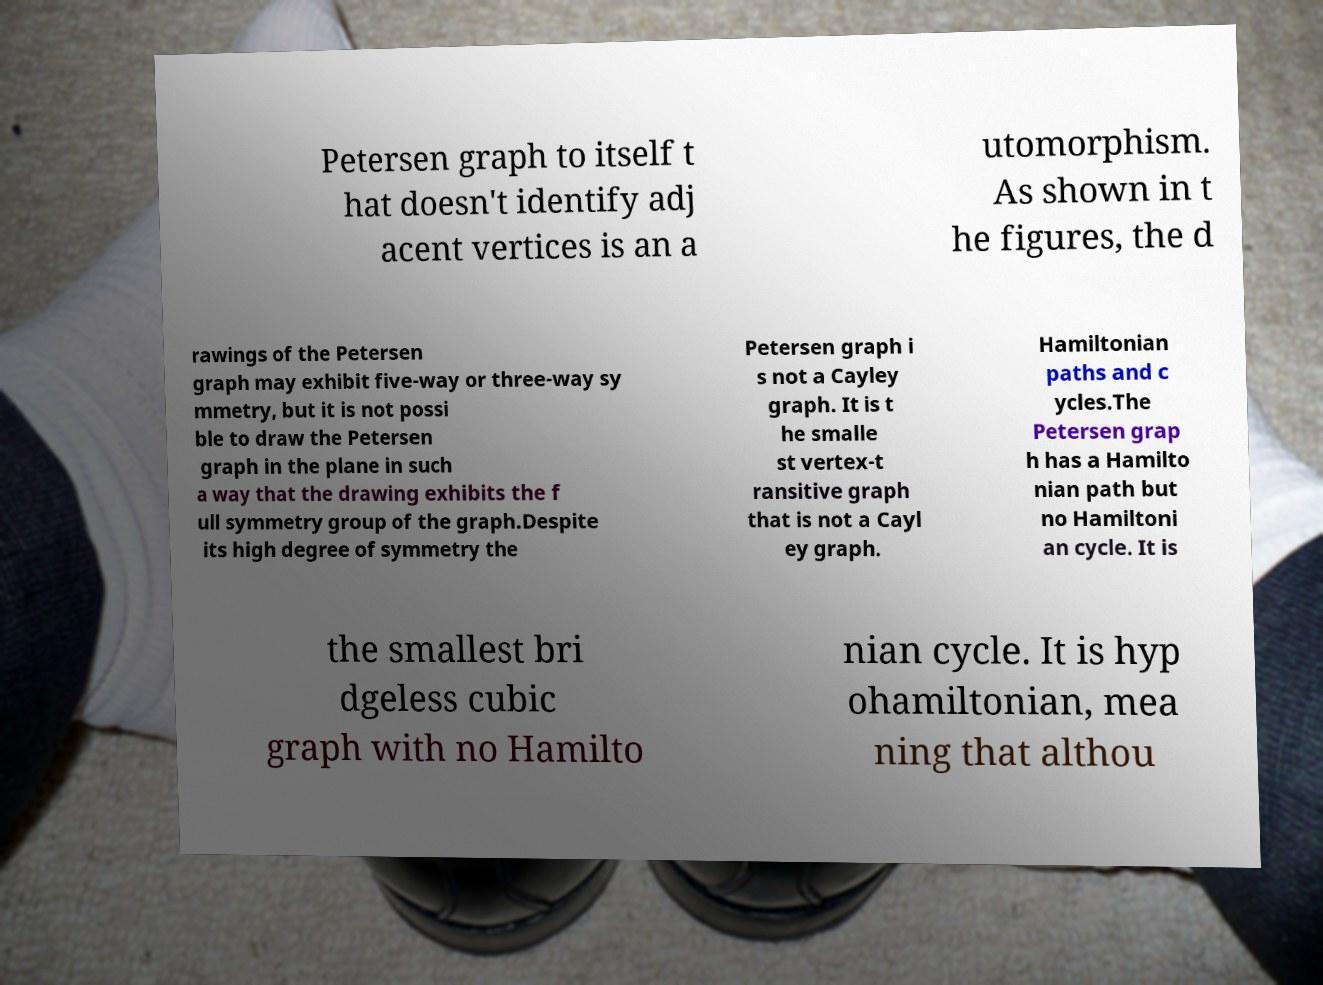Please read and relay the text visible in this image. What does it say? Petersen graph to itself t hat doesn't identify adj acent vertices is an a utomorphism. As shown in t he figures, the d rawings of the Petersen graph may exhibit five-way or three-way sy mmetry, but it is not possi ble to draw the Petersen graph in the plane in such a way that the drawing exhibits the f ull symmetry group of the graph.Despite its high degree of symmetry the Petersen graph i s not a Cayley graph. It is t he smalle st vertex-t ransitive graph that is not a Cayl ey graph. Hamiltonian paths and c ycles.The Petersen grap h has a Hamilto nian path but no Hamiltoni an cycle. It is the smallest bri dgeless cubic graph with no Hamilto nian cycle. It is hyp ohamiltonian, mea ning that althou 